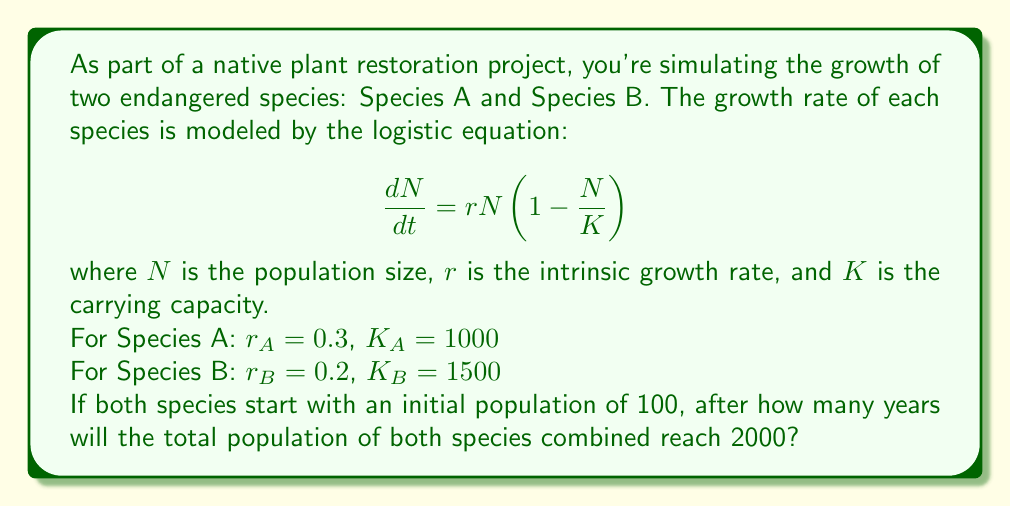Give your solution to this math problem. To solve this problem, we need to use the analytical solution of the logistic equation for each species and then find the time when their sum equals 2000. The analytical solution of the logistic equation is:

$$N(t) = \frac{K}{1 + (\frac{K}{N_0} - 1)e^{-rt}}$$

where $N_0$ is the initial population.

Step 1: Write the equations for Species A and B.

Species A: $N_A(t) = \frac{1000}{1 + (10 - 1)e^{-0.3t}}$

Species B: $N_B(t) = \frac{1500}{1 + (15 - 1)e^{-0.2t}}$

Step 2: Set up the equation to solve.

$N_A(t) + N_B(t) = 2000$

$\frac{1000}{1 + 9e^{-0.3t}} + \frac{1500}{1 + 14e^{-0.2t}} = 2000$

Step 3: This equation cannot be solved analytically, so we need to use numerical methods. We can use a simple bisection method to find the solution.

Let's define a function $f(t)$:

$f(t) = \frac{1000}{1 + 9e^{-0.3t}} + \frac{1500}{1 + 14e^{-0.2t}} - 2000$

We need to find $t$ where $f(t) = 0$.

Step 4: Implement the bisection method (pseudocode):

```
a = 0
b = 20  // An upper bound guess
tolerance = 0.001

while (b - a > tolerance):
    c = (a + b) / 2
    if f(c) == 0:
        return c
    elif f(a) * f(c) < 0:
        b = c
    else:
        a = c

return (a + b) / 2
```

Step 5: Running this algorithm (or using a computer algebra system) yields approximately 7.62 years.
Answer: 7.62 years 